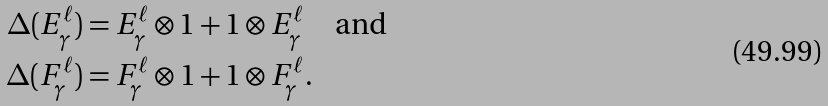<formula> <loc_0><loc_0><loc_500><loc_500>\Delta ( E _ { \gamma } ^ { \ell } ) & = E _ { \gamma } ^ { \ell } \otimes 1 + 1 \otimes E _ { \gamma } ^ { \ell } \quad \text {and} \\ \Delta ( F _ { \gamma } ^ { \ell } ) & = F _ { \gamma } ^ { \ell } \otimes 1 + 1 \otimes F _ { \gamma } ^ { \ell } .</formula> 